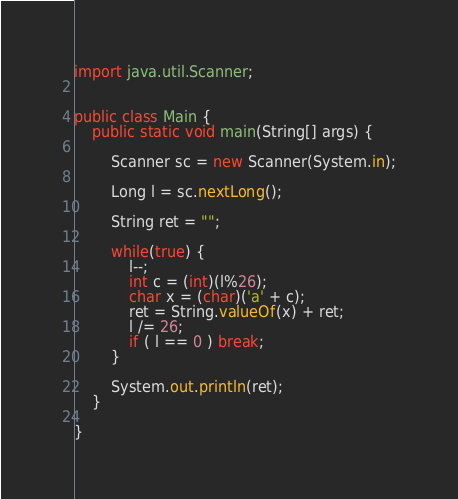<code> <loc_0><loc_0><loc_500><loc_500><_Java_>import java.util.Scanner;


public class Main {
	public static void main(String[] args) {
		
		Scanner sc = new Scanner(System.in);
		
		Long l = sc.nextLong();
		
		String ret = "";
		
		while(true) {
			l--;
			int c = (int)(l%26);
			char x = (char)('a' + c);
			ret = String.valueOf(x) + ret;
			l /= 26;
			if ( l == 0 ) break;
		}
	
		System.out.println(ret);
	}
	
}
</code> 